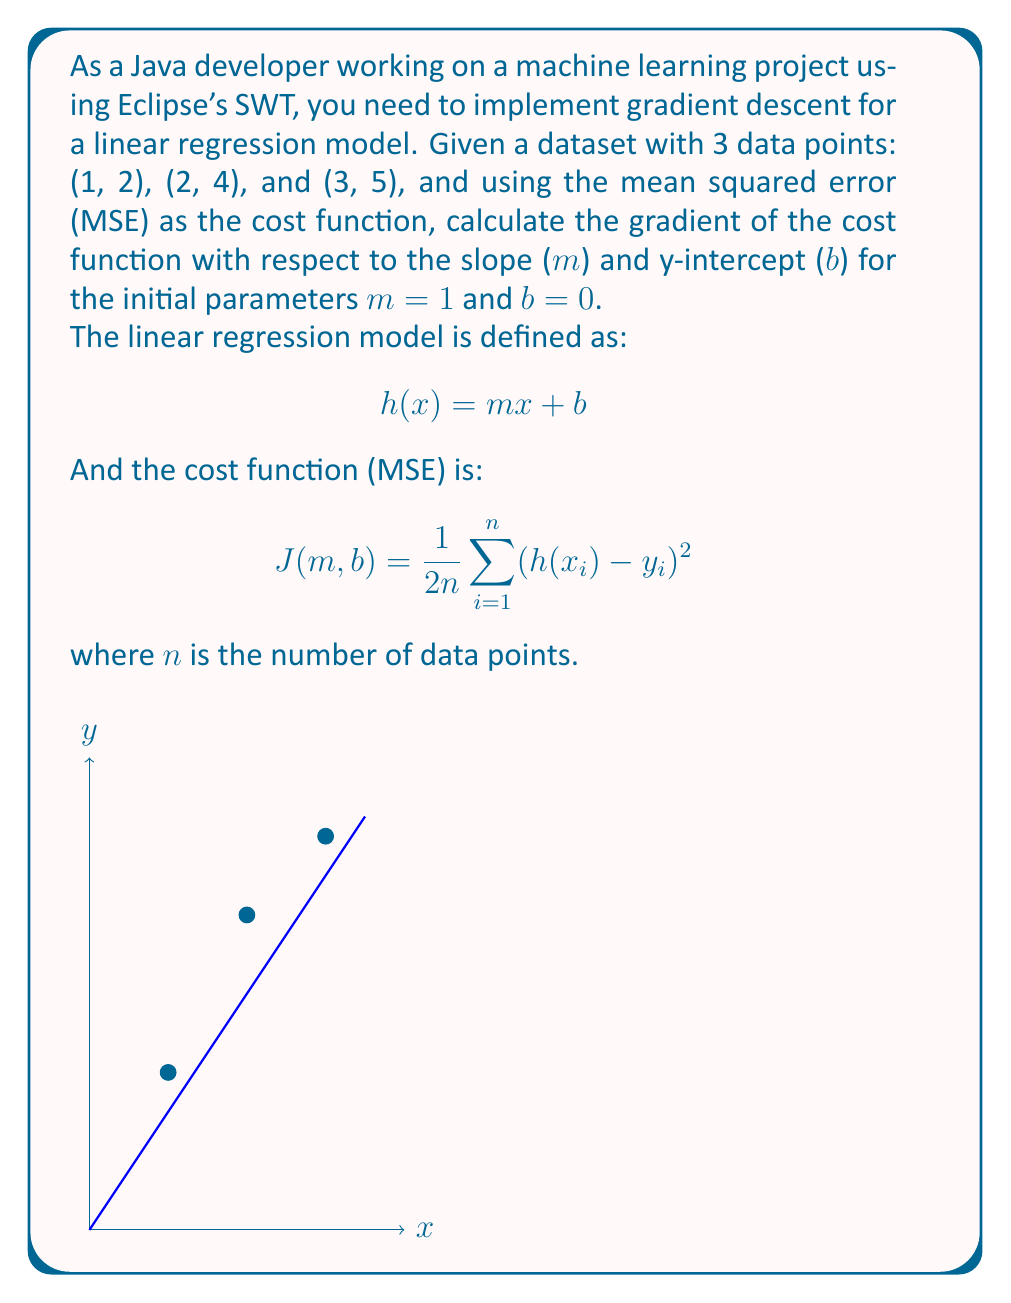Solve this math problem. Let's approach this step-by-step:

1. First, we need to calculate the predictions for each data point using the initial parameters:
   For (1, 2): $h(1) = 1 \cdot 1 + 0 = 1$
   For (2, 4): $h(2) = 1 \cdot 2 + 0 = 2$
   For (3, 5): $h(3) = 1 \cdot 3 + 0 = 3$

2. Now, we can calculate the gradients. The gradient with respect to m is:
   $$\frac{\partial J}{\partial m} = \frac{1}{n} \sum_{i=1}^n (h(x_i) - y_i) \cdot x_i$$

   And the gradient with respect to b is:
   $$\frac{\partial J}{\partial b} = \frac{1}{n} \sum_{i=1}^n (h(x_i) - y_i)$$

3. Let's calculate $\frac{\partial J}{\partial m}$:
   $$\frac{\partial J}{\partial m} = \frac{1}{3} [(1-2) \cdot 1 + (2-4) \cdot 2 + (3-5) \cdot 3]$$
   $$= \frac{1}{3} [-1 \cdot 1 + (-2) \cdot 2 + (-2) \cdot 3]$$
   $$= \frac{1}{3} [-1 - 4 - 6] = \frac{-11}{3}$$

4. Now, let's calculate $\frac{\partial J}{\partial b}$:
   $$\frac{\partial J}{\partial b} = \frac{1}{3} [(1-2) + (2-4) + (3-5)]$$
   $$= \frac{1}{3} [-1 + (-2) + (-2)]$$
   $$= \frac{1}{3} [-5] = -\frac{5}{3}$$

Therefore, the gradient of the cost function is:
$$\nabla J(m,b) = (\frac{\partial J}{\partial m}, \frac{\partial J}{\partial b}) = (-\frac{11}{3}, -\frac{5}{3})$$
Answer: $(-\frac{11}{3}, -\frac{5}{3})$ 